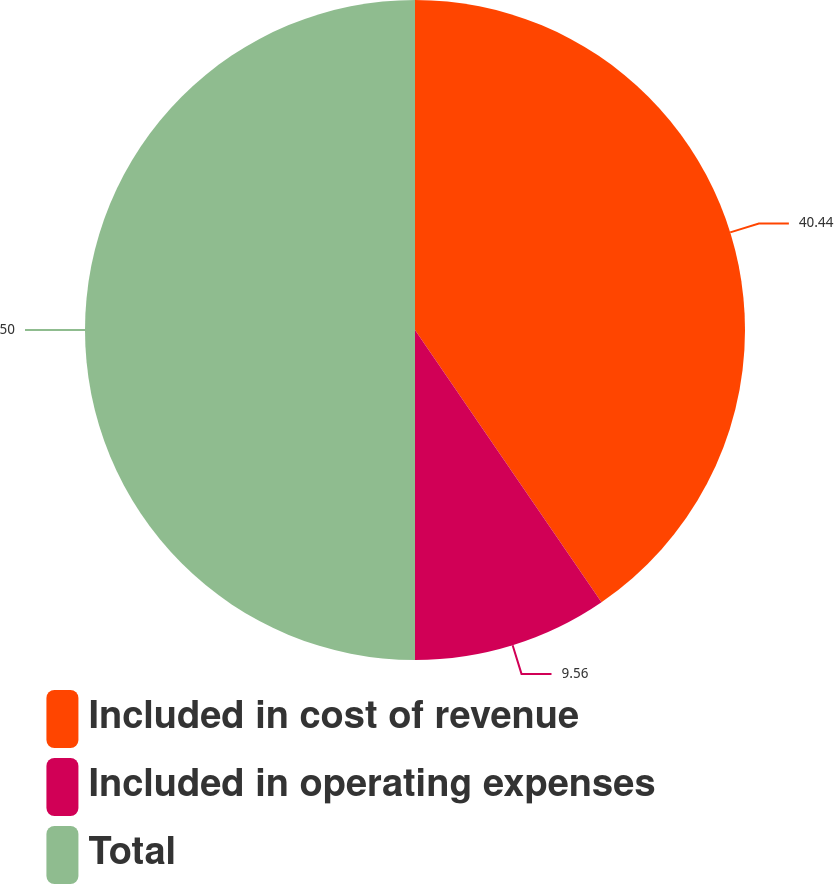Convert chart to OTSL. <chart><loc_0><loc_0><loc_500><loc_500><pie_chart><fcel>Included in cost of revenue<fcel>Included in operating expenses<fcel>Total<nl><fcel>40.44%<fcel>9.56%<fcel>50.0%<nl></chart> 